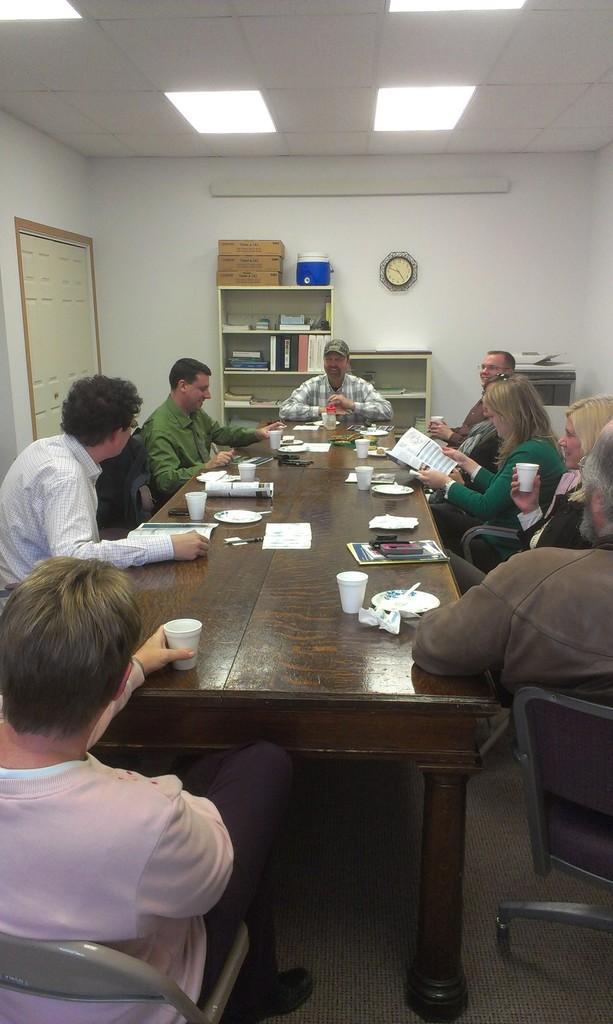Could you give a brief overview of what you see in this image? These persons are sitting on a chairs. On this table there are paper, plates and cups. A clock on wall. On this rock there are boxes and can. This rack is filled with files and books. On top there are lights. This woman is holding a book. This man is holding a cup. 